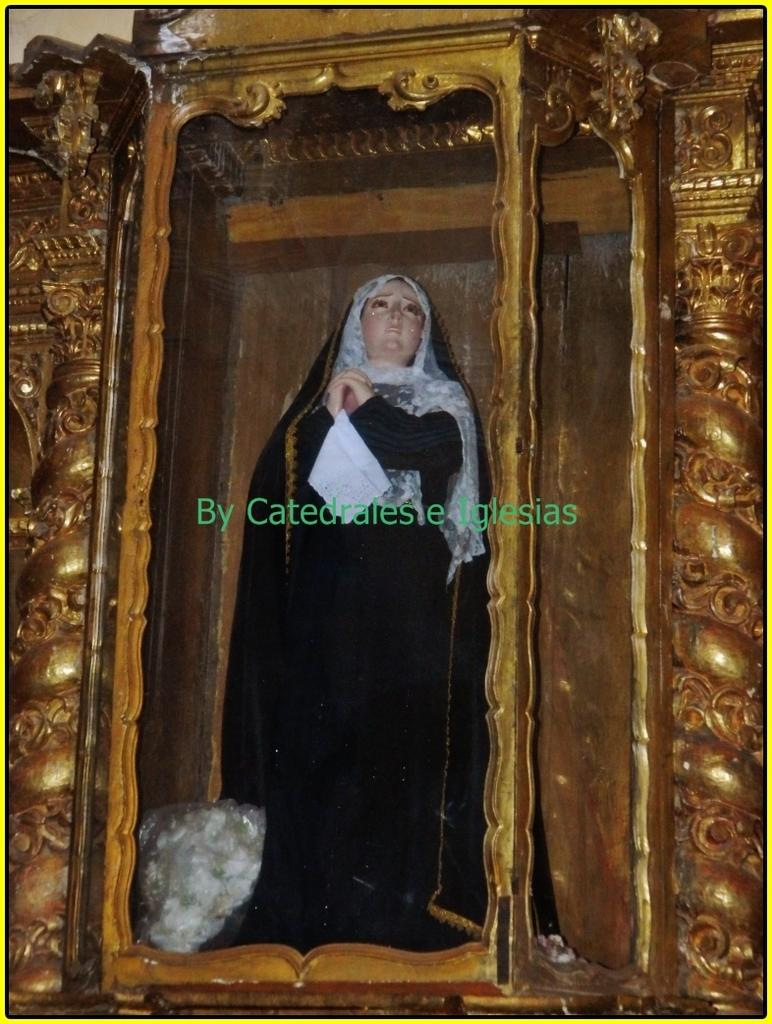What is the main subject of the image? There is a sculpture of a of a person in the image. What else can be seen in the image besides the sculpture? There is an object in a glass box in the image. Can you describe any additional features of the image? There is a watermark on the image. What color is the pot in the jail in the image? There is no pot or jail present in the image. 